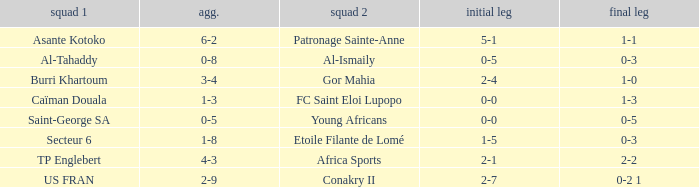Which teams had an aggregate score of 3-4? Burri Khartoum. Could you parse the entire table as a dict? {'header': ['squad 1', 'agg.', 'squad 2', 'initial leg', 'final leg'], 'rows': [['Asante Kotoko', '6-2', 'Patronage Sainte-Anne', '5-1', '1-1'], ['Al-Tahaddy', '0-8', 'Al-Ismaily', '0-5', '0-3'], ['Burri Khartoum', '3-4', 'Gor Mahia', '2-4', '1-0'], ['Caïman Douala', '1-3', 'FC Saint Eloi Lupopo', '0-0', '1-3'], ['Saint-George SA', '0-5', 'Young Africans', '0-0', '0-5'], ['Secteur 6', '1-8', 'Etoile Filante de Lomé', '1-5', '0-3'], ['TP Englebert', '4-3', 'Africa Sports', '2-1', '2-2'], ['US FRAN', '2-9', 'Conakry II', '2-7', '0-2 1']]} 